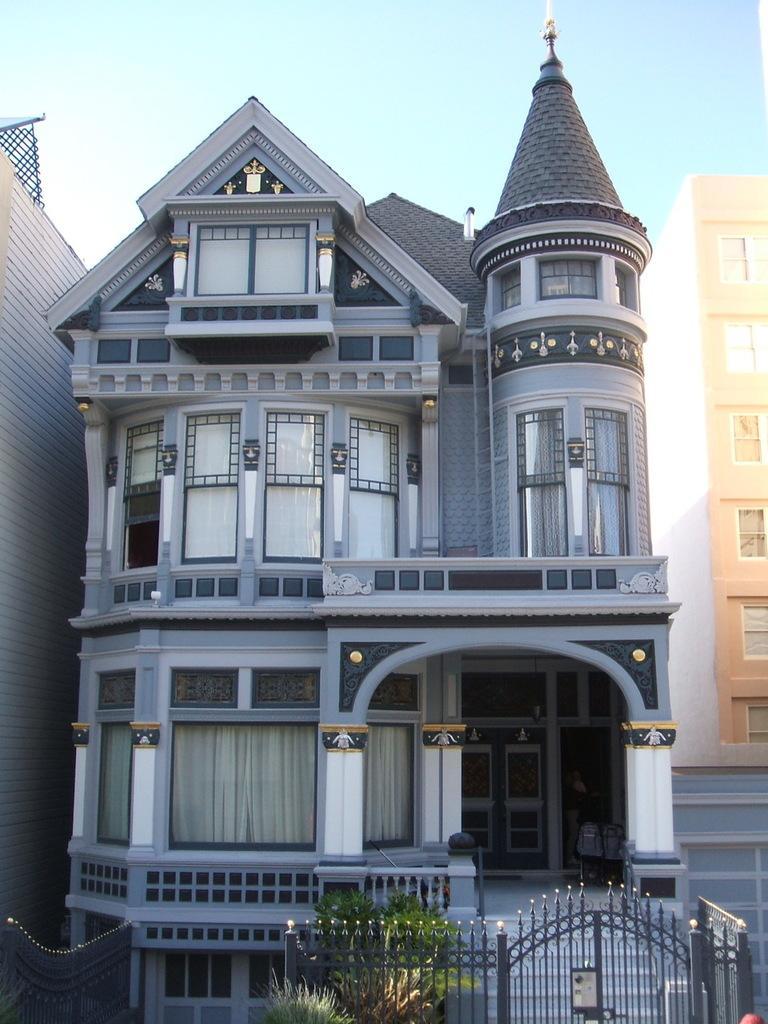In one or two sentences, can you explain what this image depicts? In this picture we can see buildings. At the top there is sky. At the bottom there are plants, gate and staircases. 